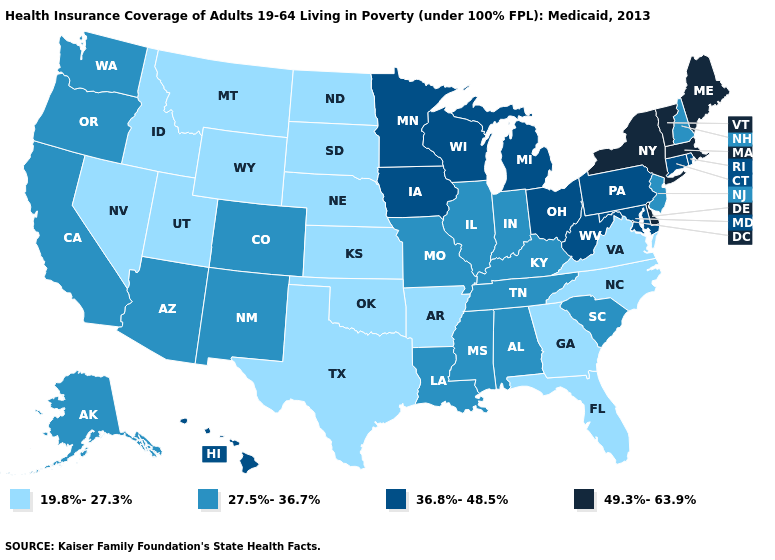Does Alaska have a higher value than Florida?
Keep it brief. Yes. What is the value of Tennessee?
Be succinct. 27.5%-36.7%. What is the value of Illinois?
Short answer required. 27.5%-36.7%. What is the value of New Jersey?
Give a very brief answer. 27.5%-36.7%. Is the legend a continuous bar?
Keep it brief. No. What is the highest value in states that border Texas?
Write a very short answer. 27.5%-36.7%. Which states have the highest value in the USA?
Concise answer only. Delaware, Maine, Massachusetts, New York, Vermont. Name the states that have a value in the range 49.3%-63.9%?
Concise answer only. Delaware, Maine, Massachusetts, New York, Vermont. Which states have the lowest value in the USA?
Write a very short answer. Arkansas, Florida, Georgia, Idaho, Kansas, Montana, Nebraska, Nevada, North Carolina, North Dakota, Oklahoma, South Dakota, Texas, Utah, Virginia, Wyoming. Among the states that border Georgia , does Florida have the lowest value?
Write a very short answer. Yes. Does Indiana have the same value as Kansas?
Give a very brief answer. No. What is the lowest value in the West?
Quick response, please. 19.8%-27.3%. Among the states that border Utah , does Wyoming have the lowest value?
Keep it brief. Yes. What is the value of Colorado?
Quick response, please. 27.5%-36.7%. Among the states that border Oregon , does California have the lowest value?
Give a very brief answer. No. 